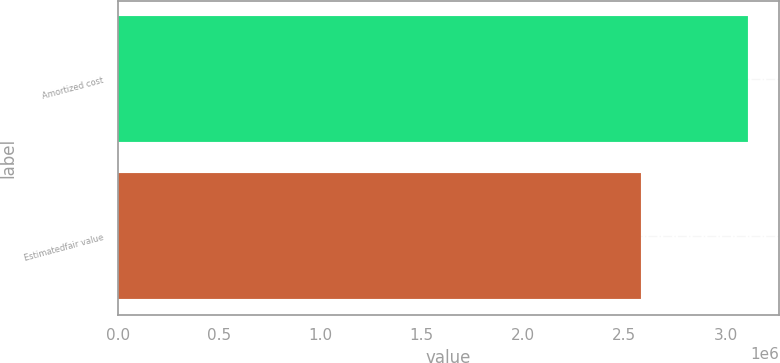Convert chart. <chart><loc_0><loc_0><loc_500><loc_500><bar_chart><fcel>Amortized cost<fcel>Estimatedfair value<nl><fcel>3.10867e+06<fcel>2.58407e+06<nl></chart> 